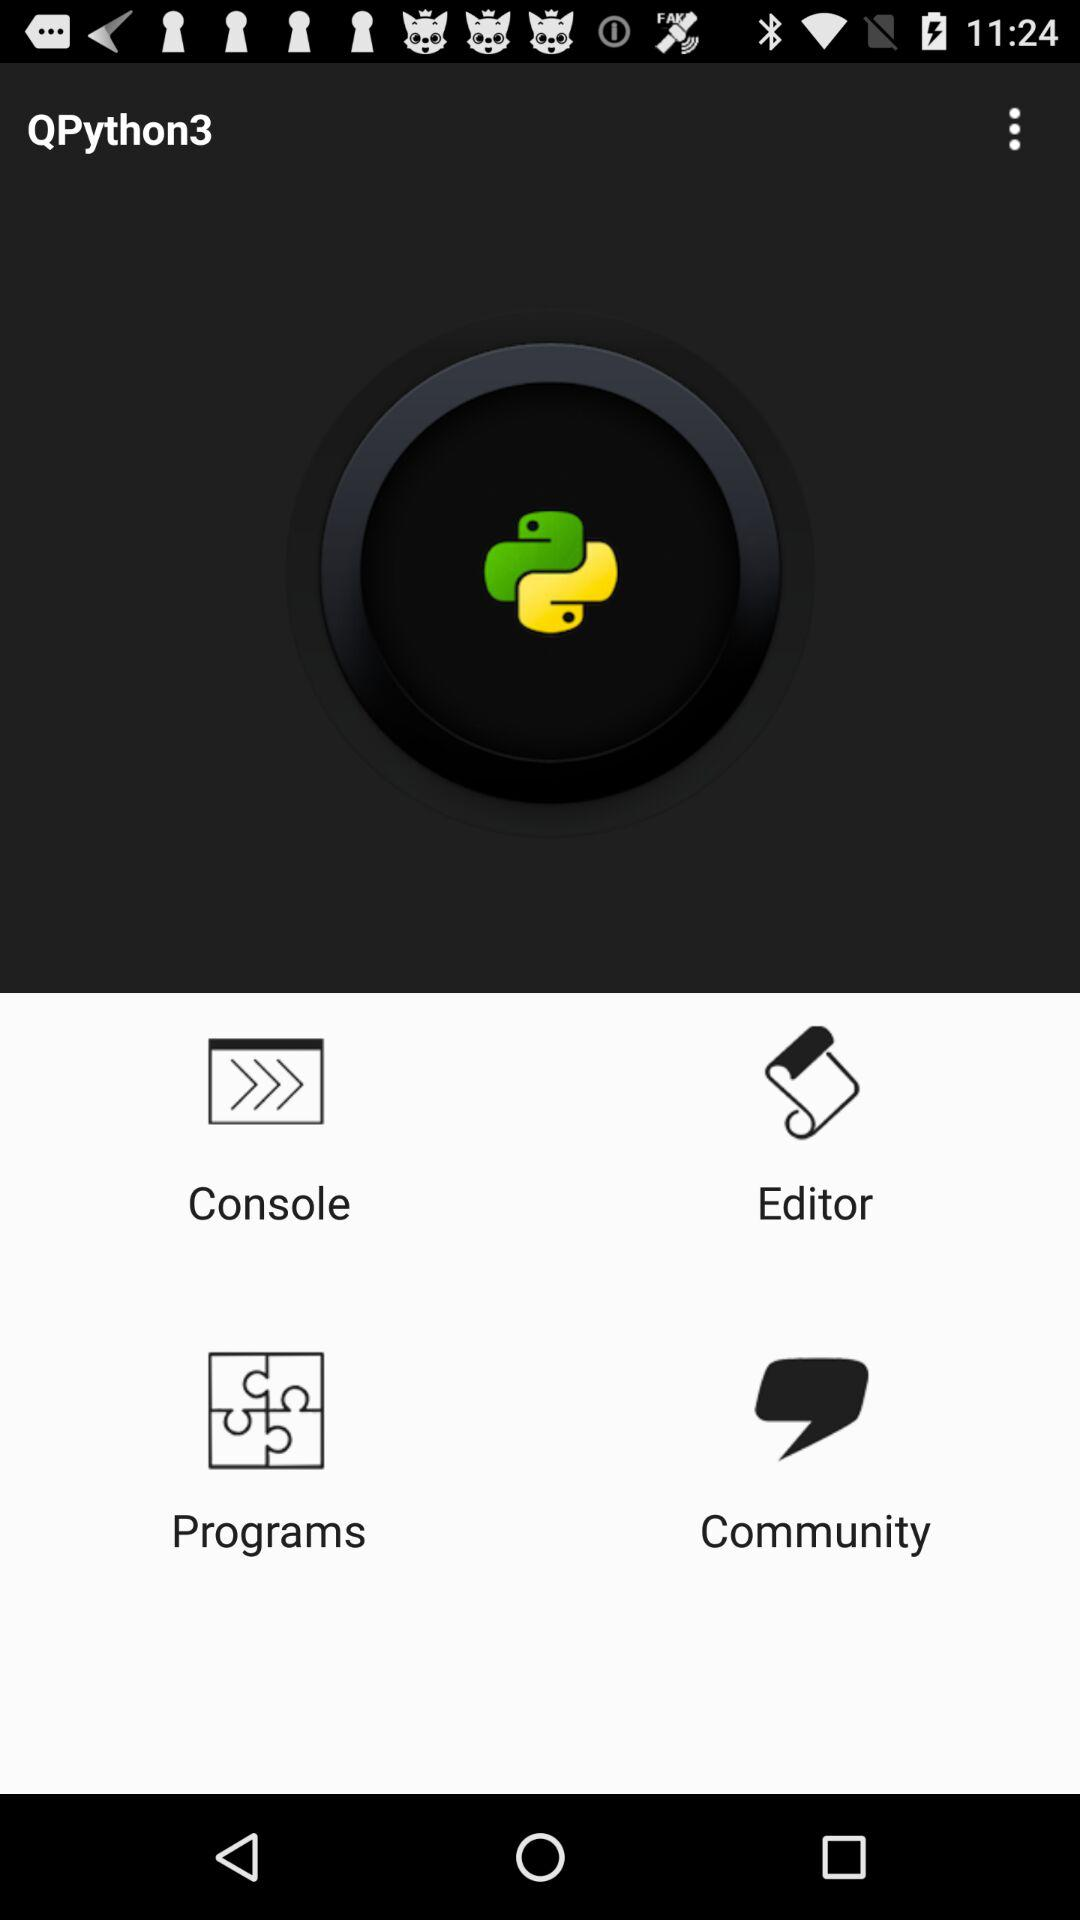What is the name of the programming language? The name of the programming language is "Python3". 